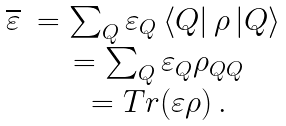<formula> <loc_0><loc_0><loc_500><loc_500>\begin{array} { c c } \overline { \varepsilon } & = \sum _ { Q } \varepsilon _ { Q } \left \langle Q \right | \rho \left | Q \right \rangle \\ & = \sum _ { Q } \varepsilon _ { Q } \rho _ { Q Q } \\ & = T r ( \varepsilon \rho ) \, . \end{array}</formula> 